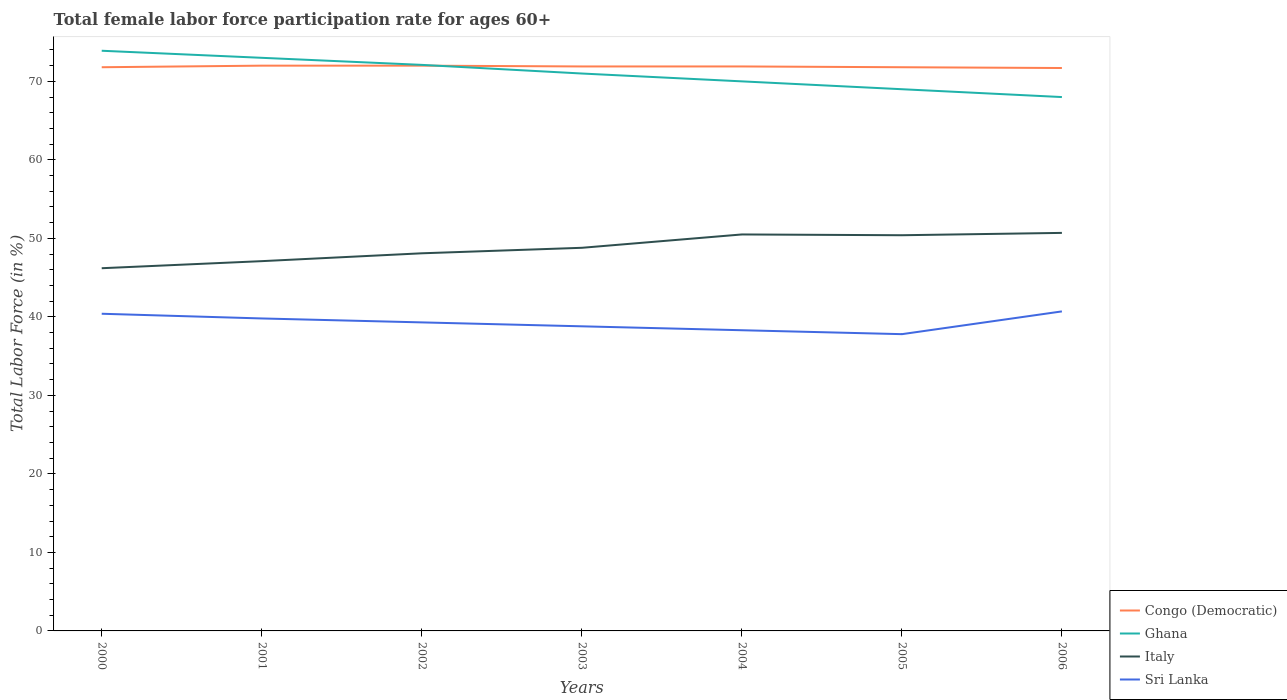How many different coloured lines are there?
Keep it short and to the point. 4. Is the number of lines equal to the number of legend labels?
Your answer should be very brief. Yes. Across all years, what is the maximum female labor force participation rate in Sri Lanka?
Provide a short and direct response. 37.8. What is the total female labor force participation rate in Sri Lanka in the graph?
Make the answer very short. 1. What is the difference between the highest and the second highest female labor force participation rate in Congo (Democratic)?
Provide a short and direct response. 0.3. Is the female labor force participation rate in Congo (Democratic) strictly greater than the female labor force participation rate in Ghana over the years?
Your answer should be very brief. No. How many lines are there?
Keep it short and to the point. 4. Are the values on the major ticks of Y-axis written in scientific E-notation?
Your answer should be very brief. No. Does the graph contain any zero values?
Your answer should be very brief. No. Does the graph contain grids?
Provide a succinct answer. No. How are the legend labels stacked?
Your response must be concise. Vertical. What is the title of the graph?
Ensure brevity in your answer.  Total female labor force participation rate for ages 60+. Does "Uganda" appear as one of the legend labels in the graph?
Give a very brief answer. No. What is the Total Labor Force (in %) in Congo (Democratic) in 2000?
Offer a terse response. 71.8. What is the Total Labor Force (in %) in Ghana in 2000?
Give a very brief answer. 73.9. What is the Total Labor Force (in %) in Italy in 2000?
Ensure brevity in your answer.  46.2. What is the Total Labor Force (in %) in Sri Lanka in 2000?
Offer a very short reply. 40.4. What is the Total Labor Force (in %) in Congo (Democratic) in 2001?
Your response must be concise. 72. What is the Total Labor Force (in %) in Ghana in 2001?
Ensure brevity in your answer.  73. What is the Total Labor Force (in %) of Italy in 2001?
Your answer should be compact. 47.1. What is the Total Labor Force (in %) in Sri Lanka in 2001?
Offer a terse response. 39.8. What is the Total Labor Force (in %) in Congo (Democratic) in 2002?
Give a very brief answer. 72. What is the Total Labor Force (in %) of Ghana in 2002?
Give a very brief answer. 72.1. What is the Total Labor Force (in %) of Italy in 2002?
Your answer should be very brief. 48.1. What is the Total Labor Force (in %) in Sri Lanka in 2002?
Provide a short and direct response. 39.3. What is the Total Labor Force (in %) in Congo (Democratic) in 2003?
Your answer should be very brief. 71.9. What is the Total Labor Force (in %) of Ghana in 2003?
Give a very brief answer. 71. What is the Total Labor Force (in %) of Italy in 2003?
Provide a short and direct response. 48.8. What is the Total Labor Force (in %) of Sri Lanka in 2003?
Provide a short and direct response. 38.8. What is the Total Labor Force (in %) in Congo (Democratic) in 2004?
Provide a short and direct response. 71.9. What is the Total Labor Force (in %) of Italy in 2004?
Provide a succinct answer. 50.5. What is the Total Labor Force (in %) of Sri Lanka in 2004?
Make the answer very short. 38.3. What is the Total Labor Force (in %) in Congo (Democratic) in 2005?
Offer a very short reply. 71.8. What is the Total Labor Force (in %) of Ghana in 2005?
Give a very brief answer. 69. What is the Total Labor Force (in %) in Italy in 2005?
Make the answer very short. 50.4. What is the Total Labor Force (in %) in Sri Lanka in 2005?
Make the answer very short. 37.8. What is the Total Labor Force (in %) in Congo (Democratic) in 2006?
Provide a succinct answer. 71.7. What is the Total Labor Force (in %) of Italy in 2006?
Offer a terse response. 50.7. What is the Total Labor Force (in %) in Sri Lanka in 2006?
Give a very brief answer. 40.7. Across all years, what is the maximum Total Labor Force (in %) in Congo (Democratic)?
Make the answer very short. 72. Across all years, what is the maximum Total Labor Force (in %) of Ghana?
Keep it short and to the point. 73.9. Across all years, what is the maximum Total Labor Force (in %) in Italy?
Make the answer very short. 50.7. Across all years, what is the maximum Total Labor Force (in %) in Sri Lanka?
Provide a succinct answer. 40.7. Across all years, what is the minimum Total Labor Force (in %) of Congo (Democratic)?
Provide a short and direct response. 71.7. Across all years, what is the minimum Total Labor Force (in %) in Italy?
Provide a succinct answer. 46.2. Across all years, what is the minimum Total Labor Force (in %) of Sri Lanka?
Your answer should be very brief. 37.8. What is the total Total Labor Force (in %) of Congo (Democratic) in the graph?
Offer a terse response. 503.1. What is the total Total Labor Force (in %) of Ghana in the graph?
Your answer should be compact. 497. What is the total Total Labor Force (in %) of Italy in the graph?
Your answer should be very brief. 341.8. What is the total Total Labor Force (in %) of Sri Lanka in the graph?
Offer a very short reply. 275.1. What is the difference between the Total Labor Force (in %) of Italy in 2000 and that in 2001?
Your answer should be compact. -0.9. What is the difference between the Total Labor Force (in %) of Sri Lanka in 2000 and that in 2001?
Offer a very short reply. 0.6. What is the difference between the Total Labor Force (in %) in Ghana in 2000 and that in 2002?
Offer a terse response. 1.8. What is the difference between the Total Labor Force (in %) of Italy in 2000 and that in 2002?
Your answer should be very brief. -1.9. What is the difference between the Total Labor Force (in %) of Congo (Democratic) in 2000 and that in 2003?
Keep it short and to the point. -0.1. What is the difference between the Total Labor Force (in %) in Sri Lanka in 2000 and that in 2003?
Provide a short and direct response. 1.6. What is the difference between the Total Labor Force (in %) of Ghana in 2000 and that in 2004?
Offer a terse response. 3.9. What is the difference between the Total Labor Force (in %) of Italy in 2000 and that in 2004?
Your answer should be compact. -4.3. What is the difference between the Total Labor Force (in %) of Sri Lanka in 2000 and that in 2004?
Offer a very short reply. 2.1. What is the difference between the Total Labor Force (in %) of Congo (Democratic) in 2000 and that in 2005?
Your answer should be compact. 0. What is the difference between the Total Labor Force (in %) in Italy in 2000 and that in 2006?
Ensure brevity in your answer.  -4.5. What is the difference between the Total Labor Force (in %) in Sri Lanka in 2001 and that in 2003?
Provide a succinct answer. 1. What is the difference between the Total Labor Force (in %) of Congo (Democratic) in 2001 and that in 2004?
Provide a short and direct response. 0.1. What is the difference between the Total Labor Force (in %) of Italy in 2001 and that in 2004?
Offer a very short reply. -3.4. What is the difference between the Total Labor Force (in %) of Sri Lanka in 2001 and that in 2004?
Your response must be concise. 1.5. What is the difference between the Total Labor Force (in %) in Sri Lanka in 2001 and that in 2006?
Offer a terse response. -0.9. What is the difference between the Total Labor Force (in %) of Congo (Democratic) in 2002 and that in 2003?
Ensure brevity in your answer.  0.1. What is the difference between the Total Labor Force (in %) in Italy in 2002 and that in 2003?
Give a very brief answer. -0.7. What is the difference between the Total Labor Force (in %) of Congo (Democratic) in 2002 and that in 2004?
Make the answer very short. 0.1. What is the difference between the Total Labor Force (in %) in Ghana in 2002 and that in 2004?
Ensure brevity in your answer.  2.1. What is the difference between the Total Labor Force (in %) of Italy in 2002 and that in 2004?
Your answer should be compact. -2.4. What is the difference between the Total Labor Force (in %) of Congo (Democratic) in 2002 and that in 2005?
Ensure brevity in your answer.  0.2. What is the difference between the Total Labor Force (in %) in Ghana in 2002 and that in 2005?
Your answer should be compact. 3.1. What is the difference between the Total Labor Force (in %) of Italy in 2002 and that in 2005?
Keep it short and to the point. -2.3. What is the difference between the Total Labor Force (in %) in Sri Lanka in 2002 and that in 2005?
Offer a very short reply. 1.5. What is the difference between the Total Labor Force (in %) of Italy in 2002 and that in 2006?
Provide a succinct answer. -2.6. What is the difference between the Total Labor Force (in %) of Congo (Democratic) in 2003 and that in 2004?
Offer a terse response. 0. What is the difference between the Total Labor Force (in %) of Ghana in 2003 and that in 2004?
Provide a succinct answer. 1. What is the difference between the Total Labor Force (in %) in Sri Lanka in 2003 and that in 2004?
Give a very brief answer. 0.5. What is the difference between the Total Labor Force (in %) of Ghana in 2003 and that in 2005?
Offer a terse response. 2. What is the difference between the Total Labor Force (in %) in Italy in 2003 and that in 2005?
Offer a very short reply. -1.6. What is the difference between the Total Labor Force (in %) in Sri Lanka in 2003 and that in 2005?
Provide a short and direct response. 1. What is the difference between the Total Labor Force (in %) in Italy in 2003 and that in 2006?
Give a very brief answer. -1.9. What is the difference between the Total Labor Force (in %) in Sri Lanka in 2003 and that in 2006?
Offer a terse response. -1.9. What is the difference between the Total Labor Force (in %) of Ghana in 2004 and that in 2005?
Provide a succinct answer. 1. What is the difference between the Total Labor Force (in %) of Ghana in 2004 and that in 2006?
Provide a succinct answer. 2. What is the difference between the Total Labor Force (in %) of Italy in 2004 and that in 2006?
Your response must be concise. -0.2. What is the difference between the Total Labor Force (in %) in Sri Lanka in 2004 and that in 2006?
Your answer should be compact. -2.4. What is the difference between the Total Labor Force (in %) in Congo (Democratic) in 2005 and that in 2006?
Ensure brevity in your answer.  0.1. What is the difference between the Total Labor Force (in %) in Ghana in 2005 and that in 2006?
Keep it short and to the point. 1. What is the difference between the Total Labor Force (in %) of Congo (Democratic) in 2000 and the Total Labor Force (in %) of Ghana in 2001?
Offer a terse response. -1.2. What is the difference between the Total Labor Force (in %) of Congo (Democratic) in 2000 and the Total Labor Force (in %) of Italy in 2001?
Provide a short and direct response. 24.7. What is the difference between the Total Labor Force (in %) of Congo (Democratic) in 2000 and the Total Labor Force (in %) of Sri Lanka in 2001?
Your response must be concise. 32. What is the difference between the Total Labor Force (in %) in Ghana in 2000 and the Total Labor Force (in %) in Italy in 2001?
Your answer should be compact. 26.8. What is the difference between the Total Labor Force (in %) in Ghana in 2000 and the Total Labor Force (in %) in Sri Lanka in 2001?
Offer a terse response. 34.1. What is the difference between the Total Labor Force (in %) in Italy in 2000 and the Total Labor Force (in %) in Sri Lanka in 2001?
Give a very brief answer. 6.4. What is the difference between the Total Labor Force (in %) of Congo (Democratic) in 2000 and the Total Labor Force (in %) of Italy in 2002?
Keep it short and to the point. 23.7. What is the difference between the Total Labor Force (in %) in Congo (Democratic) in 2000 and the Total Labor Force (in %) in Sri Lanka in 2002?
Provide a short and direct response. 32.5. What is the difference between the Total Labor Force (in %) of Ghana in 2000 and the Total Labor Force (in %) of Italy in 2002?
Offer a very short reply. 25.8. What is the difference between the Total Labor Force (in %) in Ghana in 2000 and the Total Labor Force (in %) in Sri Lanka in 2002?
Give a very brief answer. 34.6. What is the difference between the Total Labor Force (in %) of Italy in 2000 and the Total Labor Force (in %) of Sri Lanka in 2002?
Keep it short and to the point. 6.9. What is the difference between the Total Labor Force (in %) in Congo (Democratic) in 2000 and the Total Labor Force (in %) in Ghana in 2003?
Make the answer very short. 0.8. What is the difference between the Total Labor Force (in %) of Congo (Democratic) in 2000 and the Total Labor Force (in %) of Sri Lanka in 2003?
Ensure brevity in your answer.  33. What is the difference between the Total Labor Force (in %) of Ghana in 2000 and the Total Labor Force (in %) of Italy in 2003?
Your answer should be compact. 25.1. What is the difference between the Total Labor Force (in %) of Ghana in 2000 and the Total Labor Force (in %) of Sri Lanka in 2003?
Ensure brevity in your answer.  35.1. What is the difference between the Total Labor Force (in %) in Italy in 2000 and the Total Labor Force (in %) in Sri Lanka in 2003?
Keep it short and to the point. 7.4. What is the difference between the Total Labor Force (in %) in Congo (Democratic) in 2000 and the Total Labor Force (in %) in Ghana in 2004?
Your answer should be compact. 1.8. What is the difference between the Total Labor Force (in %) in Congo (Democratic) in 2000 and the Total Labor Force (in %) in Italy in 2004?
Offer a very short reply. 21.3. What is the difference between the Total Labor Force (in %) of Congo (Democratic) in 2000 and the Total Labor Force (in %) of Sri Lanka in 2004?
Your answer should be very brief. 33.5. What is the difference between the Total Labor Force (in %) of Ghana in 2000 and the Total Labor Force (in %) of Italy in 2004?
Make the answer very short. 23.4. What is the difference between the Total Labor Force (in %) in Ghana in 2000 and the Total Labor Force (in %) in Sri Lanka in 2004?
Keep it short and to the point. 35.6. What is the difference between the Total Labor Force (in %) in Italy in 2000 and the Total Labor Force (in %) in Sri Lanka in 2004?
Offer a very short reply. 7.9. What is the difference between the Total Labor Force (in %) of Congo (Democratic) in 2000 and the Total Labor Force (in %) of Ghana in 2005?
Provide a short and direct response. 2.8. What is the difference between the Total Labor Force (in %) in Congo (Democratic) in 2000 and the Total Labor Force (in %) in Italy in 2005?
Provide a short and direct response. 21.4. What is the difference between the Total Labor Force (in %) of Congo (Democratic) in 2000 and the Total Labor Force (in %) of Sri Lanka in 2005?
Your answer should be compact. 34. What is the difference between the Total Labor Force (in %) of Ghana in 2000 and the Total Labor Force (in %) of Sri Lanka in 2005?
Keep it short and to the point. 36.1. What is the difference between the Total Labor Force (in %) of Italy in 2000 and the Total Labor Force (in %) of Sri Lanka in 2005?
Give a very brief answer. 8.4. What is the difference between the Total Labor Force (in %) in Congo (Democratic) in 2000 and the Total Labor Force (in %) in Ghana in 2006?
Offer a very short reply. 3.8. What is the difference between the Total Labor Force (in %) in Congo (Democratic) in 2000 and the Total Labor Force (in %) in Italy in 2006?
Make the answer very short. 21.1. What is the difference between the Total Labor Force (in %) of Congo (Democratic) in 2000 and the Total Labor Force (in %) of Sri Lanka in 2006?
Offer a terse response. 31.1. What is the difference between the Total Labor Force (in %) of Ghana in 2000 and the Total Labor Force (in %) of Italy in 2006?
Give a very brief answer. 23.2. What is the difference between the Total Labor Force (in %) in Ghana in 2000 and the Total Labor Force (in %) in Sri Lanka in 2006?
Provide a succinct answer. 33.2. What is the difference between the Total Labor Force (in %) of Congo (Democratic) in 2001 and the Total Labor Force (in %) of Italy in 2002?
Offer a very short reply. 23.9. What is the difference between the Total Labor Force (in %) of Congo (Democratic) in 2001 and the Total Labor Force (in %) of Sri Lanka in 2002?
Offer a very short reply. 32.7. What is the difference between the Total Labor Force (in %) in Ghana in 2001 and the Total Labor Force (in %) in Italy in 2002?
Provide a succinct answer. 24.9. What is the difference between the Total Labor Force (in %) of Ghana in 2001 and the Total Labor Force (in %) of Sri Lanka in 2002?
Offer a very short reply. 33.7. What is the difference between the Total Labor Force (in %) of Congo (Democratic) in 2001 and the Total Labor Force (in %) of Ghana in 2003?
Provide a succinct answer. 1. What is the difference between the Total Labor Force (in %) in Congo (Democratic) in 2001 and the Total Labor Force (in %) in Italy in 2003?
Make the answer very short. 23.2. What is the difference between the Total Labor Force (in %) in Congo (Democratic) in 2001 and the Total Labor Force (in %) in Sri Lanka in 2003?
Ensure brevity in your answer.  33.2. What is the difference between the Total Labor Force (in %) of Ghana in 2001 and the Total Labor Force (in %) of Italy in 2003?
Give a very brief answer. 24.2. What is the difference between the Total Labor Force (in %) in Ghana in 2001 and the Total Labor Force (in %) in Sri Lanka in 2003?
Provide a short and direct response. 34.2. What is the difference between the Total Labor Force (in %) in Italy in 2001 and the Total Labor Force (in %) in Sri Lanka in 2003?
Give a very brief answer. 8.3. What is the difference between the Total Labor Force (in %) of Congo (Democratic) in 2001 and the Total Labor Force (in %) of Sri Lanka in 2004?
Offer a terse response. 33.7. What is the difference between the Total Labor Force (in %) of Ghana in 2001 and the Total Labor Force (in %) of Italy in 2004?
Give a very brief answer. 22.5. What is the difference between the Total Labor Force (in %) in Ghana in 2001 and the Total Labor Force (in %) in Sri Lanka in 2004?
Make the answer very short. 34.7. What is the difference between the Total Labor Force (in %) in Congo (Democratic) in 2001 and the Total Labor Force (in %) in Italy in 2005?
Offer a very short reply. 21.6. What is the difference between the Total Labor Force (in %) of Congo (Democratic) in 2001 and the Total Labor Force (in %) of Sri Lanka in 2005?
Your answer should be compact. 34.2. What is the difference between the Total Labor Force (in %) in Ghana in 2001 and the Total Labor Force (in %) in Italy in 2005?
Provide a short and direct response. 22.6. What is the difference between the Total Labor Force (in %) in Ghana in 2001 and the Total Labor Force (in %) in Sri Lanka in 2005?
Ensure brevity in your answer.  35.2. What is the difference between the Total Labor Force (in %) of Italy in 2001 and the Total Labor Force (in %) of Sri Lanka in 2005?
Offer a terse response. 9.3. What is the difference between the Total Labor Force (in %) of Congo (Democratic) in 2001 and the Total Labor Force (in %) of Ghana in 2006?
Your answer should be very brief. 4. What is the difference between the Total Labor Force (in %) in Congo (Democratic) in 2001 and the Total Labor Force (in %) in Italy in 2006?
Offer a very short reply. 21.3. What is the difference between the Total Labor Force (in %) in Congo (Democratic) in 2001 and the Total Labor Force (in %) in Sri Lanka in 2006?
Keep it short and to the point. 31.3. What is the difference between the Total Labor Force (in %) in Ghana in 2001 and the Total Labor Force (in %) in Italy in 2006?
Offer a terse response. 22.3. What is the difference between the Total Labor Force (in %) of Ghana in 2001 and the Total Labor Force (in %) of Sri Lanka in 2006?
Provide a succinct answer. 32.3. What is the difference between the Total Labor Force (in %) in Italy in 2001 and the Total Labor Force (in %) in Sri Lanka in 2006?
Offer a terse response. 6.4. What is the difference between the Total Labor Force (in %) of Congo (Democratic) in 2002 and the Total Labor Force (in %) of Italy in 2003?
Offer a terse response. 23.2. What is the difference between the Total Labor Force (in %) of Congo (Democratic) in 2002 and the Total Labor Force (in %) of Sri Lanka in 2003?
Keep it short and to the point. 33.2. What is the difference between the Total Labor Force (in %) of Ghana in 2002 and the Total Labor Force (in %) of Italy in 2003?
Your answer should be very brief. 23.3. What is the difference between the Total Labor Force (in %) of Ghana in 2002 and the Total Labor Force (in %) of Sri Lanka in 2003?
Your answer should be compact. 33.3. What is the difference between the Total Labor Force (in %) of Italy in 2002 and the Total Labor Force (in %) of Sri Lanka in 2003?
Ensure brevity in your answer.  9.3. What is the difference between the Total Labor Force (in %) of Congo (Democratic) in 2002 and the Total Labor Force (in %) of Italy in 2004?
Ensure brevity in your answer.  21.5. What is the difference between the Total Labor Force (in %) in Congo (Democratic) in 2002 and the Total Labor Force (in %) in Sri Lanka in 2004?
Your answer should be compact. 33.7. What is the difference between the Total Labor Force (in %) in Ghana in 2002 and the Total Labor Force (in %) in Italy in 2004?
Provide a succinct answer. 21.6. What is the difference between the Total Labor Force (in %) of Ghana in 2002 and the Total Labor Force (in %) of Sri Lanka in 2004?
Offer a terse response. 33.8. What is the difference between the Total Labor Force (in %) in Congo (Democratic) in 2002 and the Total Labor Force (in %) in Ghana in 2005?
Ensure brevity in your answer.  3. What is the difference between the Total Labor Force (in %) of Congo (Democratic) in 2002 and the Total Labor Force (in %) of Italy in 2005?
Provide a succinct answer. 21.6. What is the difference between the Total Labor Force (in %) of Congo (Democratic) in 2002 and the Total Labor Force (in %) of Sri Lanka in 2005?
Your answer should be compact. 34.2. What is the difference between the Total Labor Force (in %) of Ghana in 2002 and the Total Labor Force (in %) of Italy in 2005?
Keep it short and to the point. 21.7. What is the difference between the Total Labor Force (in %) of Ghana in 2002 and the Total Labor Force (in %) of Sri Lanka in 2005?
Keep it short and to the point. 34.3. What is the difference between the Total Labor Force (in %) in Italy in 2002 and the Total Labor Force (in %) in Sri Lanka in 2005?
Make the answer very short. 10.3. What is the difference between the Total Labor Force (in %) in Congo (Democratic) in 2002 and the Total Labor Force (in %) in Italy in 2006?
Your answer should be compact. 21.3. What is the difference between the Total Labor Force (in %) of Congo (Democratic) in 2002 and the Total Labor Force (in %) of Sri Lanka in 2006?
Provide a short and direct response. 31.3. What is the difference between the Total Labor Force (in %) of Ghana in 2002 and the Total Labor Force (in %) of Italy in 2006?
Give a very brief answer. 21.4. What is the difference between the Total Labor Force (in %) in Ghana in 2002 and the Total Labor Force (in %) in Sri Lanka in 2006?
Ensure brevity in your answer.  31.4. What is the difference between the Total Labor Force (in %) of Congo (Democratic) in 2003 and the Total Labor Force (in %) of Ghana in 2004?
Offer a very short reply. 1.9. What is the difference between the Total Labor Force (in %) in Congo (Democratic) in 2003 and the Total Labor Force (in %) in Italy in 2004?
Your answer should be very brief. 21.4. What is the difference between the Total Labor Force (in %) in Congo (Democratic) in 2003 and the Total Labor Force (in %) in Sri Lanka in 2004?
Offer a terse response. 33.6. What is the difference between the Total Labor Force (in %) of Ghana in 2003 and the Total Labor Force (in %) of Italy in 2004?
Offer a terse response. 20.5. What is the difference between the Total Labor Force (in %) of Ghana in 2003 and the Total Labor Force (in %) of Sri Lanka in 2004?
Your answer should be very brief. 32.7. What is the difference between the Total Labor Force (in %) in Congo (Democratic) in 2003 and the Total Labor Force (in %) in Ghana in 2005?
Provide a succinct answer. 2.9. What is the difference between the Total Labor Force (in %) in Congo (Democratic) in 2003 and the Total Labor Force (in %) in Italy in 2005?
Give a very brief answer. 21.5. What is the difference between the Total Labor Force (in %) of Congo (Democratic) in 2003 and the Total Labor Force (in %) of Sri Lanka in 2005?
Your answer should be compact. 34.1. What is the difference between the Total Labor Force (in %) of Ghana in 2003 and the Total Labor Force (in %) of Italy in 2005?
Your response must be concise. 20.6. What is the difference between the Total Labor Force (in %) of Ghana in 2003 and the Total Labor Force (in %) of Sri Lanka in 2005?
Provide a short and direct response. 33.2. What is the difference between the Total Labor Force (in %) in Italy in 2003 and the Total Labor Force (in %) in Sri Lanka in 2005?
Provide a short and direct response. 11. What is the difference between the Total Labor Force (in %) in Congo (Democratic) in 2003 and the Total Labor Force (in %) in Italy in 2006?
Make the answer very short. 21.2. What is the difference between the Total Labor Force (in %) in Congo (Democratic) in 2003 and the Total Labor Force (in %) in Sri Lanka in 2006?
Offer a terse response. 31.2. What is the difference between the Total Labor Force (in %) of Ghana in 2003 and the Total Labor Force (in %) of Italy in 2006?
Your response must be concise. 20.3. What is the difference between the Total Labor Force (in %) of Ghana in 2003 and the Total Labor Force (in %) of Sri Lanka in 2006?
Give a very brief answer. 30.3. What is the difference between the Total Labor Force (in %) in Congo (Democratic) in 2004 and the Total Labor Force (in %) in Italy in 2005?
Provide a short and direct response. 21.5. What is the difference between the Total Labor Force (in %) in Congo (Democratic) in 2004 and the Total Labor Force (in %) in Sri Lanka in 2005?
Ensure brevity in your answer.  34.1. What is the difference between the Total Labor Force (in %) of Ghana in 2004 and the Total Labor Force (in %) of Italy in 2005?
Give a very brief answer. 19.6. What is the difference between the Total Labor Force (in %) in Ghana in 2004 and the Total Labor Force (in %) in Sri Lanka in 2005?
Ensure brevity in your answer.  32.2. What is the difference between the Total Labor Force (in %) in Italy in 2004 and the Total Labor Force (in %) in Sri Lanka in 2005?
Your response must be concise. 12.7. What is the difference between the Total Labor Force (in %) of Congo (Democratic) in 2004 and the Total Labor Force (in %) of Italy in 2006?
Your answer should be very brief. 21.2. What is the difference between the Total Labor Force (in %) in Congo (Democratic) in 2004 and the Total Labor Force (in %) in Sri Lanka in 2006?
Offer a terse response. 31.2. What is the difference between the Total Labor Force (in %) of Ghana in 2004 and the Total Labor Force (in %) of Italy in 2006?
Provide a short and direct response. 19.3. What is the difference between the Total Labor Force (in %) in Ghana in 2004 and the Total Labor Force (in %) in Sri Lanka in 2006?
Give a very brief answer. 29.3. What is the difference between the Total Labor Force (in %) of Italy in 2004 and the Total Labor Force (in %) of Sri Lanka in 2006?
Give a very brief answer. 9.8. What is the difference between the Total Labor Force (in %) of Congo (Democratic) in 2005 and the Total Labor Force (in %) of Italy in 2006?
Your answer should be very brief. 21.1. What is the difference between the Total Labor Force (in %) of Congo (Democratic) in 2005 and the Total Labor Force (in %) of Sri Lanka in 2006?
Your answer should be compact. 31.1. What is the difference between the Total Labor Force (in %) in Ghana in 2005 and the Total Labor Force (in %) in Sri Lanka in 2006?
Give a very brief answer. 28.3. What is the average Total Labor Force (in %) in Congo (Democratic) per year?
Give a very brief answer. 71.87. What is the average Total Labor Force (in %) in Ghana per year?
Your answer should be compact. 71. What is the average Total Labor Force (in %) in Italy per year?
Offer a very short reply. 48.83. What is the average Total Labor Force (in %) of Sri Lanka per year?
Provide a short and direct response. 39.3. In the year 2000, what is the difference between the Total Labor Force (in %) in Congo (Democratic) and Total Labor Force (in %) in Ghana?
Keep it short and to the point. -2.1. In the year 2000, what is the difference between the Total Labor Force (in %) in Congo (Democratic) and Total Labor Force (in %) in Italy?
Make the answer very short. 25.6. In the year 2000, what is the difference between the Total Labor Force (in %) in Congo (Democratic) and Total Labor Force (in %) in Sri Lanka?
Your answer should be compact. 31.4. In the year 2000, what is the difference between the Total Labor Force (in %) of Ghana and Total Labor Force (in %) of Italy?
Ensure brevity in your answer.  27.7. In the year 2000, what is the difference between the Total Labor Force (in %) in Ghana and Total Labor Force (in %) in Sri Lanka?
Your answer should be very brief. 33.5. In the year 2001, what is the difference between the Total Labor Force (in %) in Congo (Democratic) and Total Labor Force (in %) in Ghana?
Give a very brief answer. -1. In the year 2001, what is the difference between the Total Labor Force (in %) in Congo (Democratic) and Total Labor Force (in %) in Italy?
Your answer should be very brief. 24.9. In the year 2001, what is the difference between the Total Labor Force (in %) of Congo (Democratic) and Total Labor Force (in %) of Sri Lanka?
Provide a succinct answer. 32.2. In the year 2001, what is the difference between the Total Labor Force (in %) in Ghana and Total Labor Force (in %) in Italy?
Offer a very short reply. 25.9. In the year 2001, what is the difference between the Total Labor Force (in %) of Ghana and Total Labor Force (in %) of Sri Lanka?
Give a very brief answer. 33.2. In the year 2001, what is the difference between the Total Labor Force (in %) of Italy and Total Labor Force (in %) of Sri Lanka?
Ensure brevity in your answer.  7.3. In the year 2002, what is the difference between the Total Labor Force (in %) of Congo (Democratic) and Total Labor Force (in %) of Ghana?
Your response must be concise. -0.1. In the year 2002, what is the difference between the Total Labor Force (in %) of Congo (Democratic) and Total Labor Force (in %) of Italy?
Offer a very short reply. 23.9. In the year 2002, what is the difference between the Total Labor Force (in %) of Congo (Democratic) and Total Labor Force (in %) of Sri Lanka?
Offer a terse response. 32.7. In the year 2002, what is the difference between the Total Labor Force (in %) of Ghana and Total Labor Force (in %) of Sri Lanka?
Offer a terse response. 32.8. In the year 2002, what is the difference between the Total Labor Force (in %) in Italy and Total Labor Force (in %) in Sri Lanka?
Make the answer very short. 8.8. In the year 2003, what is the difference between the Total Labor Force (in %) of Congo (Democratic) and Total Labor Force (in %) of Ghana?
Your answer should be very brief. 0.9. In the year 2003, what is the difference between the Total Labor Force (in %) in Congo (Democratic) and Total Labor Force (in %) in Italy?
Offer a very short reply. 23.1. In the year 2003, what is the difference between the Total Labor Force (in %) in Congo (Democratic) and Total Labor Force (in %) in Sri Lanka?
Your answer should be very brief. 33.1. In the year 2003, what is the difference between the Total Labor Force (in %) in Ghana and Total Labor Force (in %) in Italy?
Offer a very short reply. 22.2. In the year 2003, what is the difference between the Total Labor Force (in %) of Ghana and Total Labor Force (in %) of Sri Lanka?
Give a very brief answer. 32.2. In the year 2004, what is the difference between the Total Labor Force (in %) in Congo (Democratic) and Total Labor Force (in %) in Italy?
Offer a very short reply. 21.4. In the year 2004, what is the difference between the Total Labor Force (in %) of Congo (Democratic) and Total Labor Force (in %) of Sri Lanka?
Offer a very short reply. 33.6. In the year 2004, what is the difference between the Total Labor Force (in %) in Ghana and Total Labor Force (in %) in Italy?
Give a very brief answer. 19.5. In the year 2004, what is the difference between the Total Labor Force (in %) of Ghana and Total Labor Force (in %) of Sri Lanka?
Your response must be concise. 31.7. In the year 2005, what is the difference between the Total Labor Force (in %) in Congo (Democratic) and Total Labor Force (in %) in Italy?
Ensure brevity in your answer.  21.4. In the year 2005, what is the difference between the Total Labor Force (in %) in Congo (Democratic) and Total Labor Force (in %) in Sri Lanka?
Make the answer very short. 34. In the year 2005, what is the difference between the Total Labor Force (in %) in Ghana and Total Labor Force (in %) in Sri Lanka?
Provide a succinct answer. 31.2. In the year 2006, what is the difference between the Total Labor Force (in %) of Congo (Democratic) and Total Labor Force (in %) of Italy?
Offer a terse response. 21. In the year 2006, what is the difference between the Total Labor Force (in %) of Congo (Democratic) and Total Labor Force (in %) of Sri Lanka?
Provide a succinct answer. 31. In the year 2006, what is the difference between the Total Labor Force (in %) of Ghana and Total Labor Force (in %) of Sri Lanka?
Your answer should be very brief. 27.3. In the year 2006, what is the difference between the Total Labor Force (in %) of Italy and Total Labor Force (in %) of Sri Lanka?
Your answer should be compact. 10. What is the ratio of the Total Labor Force (in %) in Ghana in 2000 to that in 2001?
Your answer should be very brief. 1.01. What is the ratio of the Total Labor Force (in %) of Italy in 2000 to that in 2001?
Your answer should be very brief. 0.98. What is the ratio of the Total Labor Force (in %) of Sri Lanka in 2000 to that in 2001?
Ensure brevity in your answer.  1.02. What is the ratio of the Total Labor Force (in %) in Congo (Democratic) in 2000 to that in 2002?
Provide a short and direct response. 1. What is the ratio of the Total Labor Force (in %) of Italy in 2000 to that in 2002?
Your answer should be very brief. 0.96. What is the ratio of the Total Labor Force (in %) of Sri Lanka in 2000 to that in 2002?
Provide a succinct answer. 1.03. What is the ratio of the Total Labor Force (in %) in Congo (Democratic) in 2000 to that in 2003?
Provide a short and direct response. 1. What is the ratio of the Total Labor Force (in %) of Ghana in 2000 to that in 2003?
Your answer should be very brief. 1.04. What is the ratio of the Total Labor Force (in %) in Italy in 2000 to that in 2003?
Make the answer very short. 0.95. What is the ratio of the Total Labor Force (in %) of Sri Lanka in 2000 to that in 2003?
Your answer should be compact. 1.04. What is the ratio of the Total Labor Force (in %) in Ghana in 2000 to that in 2004?
Keep it short and to the point. 1.06. What is the ratio of the Total Labor Force (in %) in Italy in 2000 to that in 2004?
Your answer should be compact. 0.91. What is the ratio of the Total Labor Force (in %) of Sri Lanka in 2000 to that in 2004?
Your response must be concise. 1.05. What is the ratio of the Total Labor Force (in %) in Congo (Democratic) in 2000 to that in 2005?
Keep it short and to the point. 1. What is the ratio of the Total Labor Force (in %) in Ghana in 2000 to that in 2005?
Provide a short and direct response. 1.07. What is the ratio of the Total Labor Force (in %) of Italy in 2000 to that in 2005?
Your answer should be compact. 0.92. What is the ratio of the Total Labor Force (in %) of Sri Lanka in 2000 to that in 2005?
Offer a terse response. 1.07. What is the ratio of the Total Labor Force (in %) of Ghana in 2000 to that in 2006?
Your response must be concise. 1.09. What is the ratio of the Total Labor Force (in %) in Italy in 2000 to that in 2006?
Offer a terse response. 0.91. What is the ratio of the Total Labor Force (in %) of Congo (Democratic) in 2001 to that in 2002?
Offer a terse response. 1. What is the ratio of the Total Labor Force (in %) of Ghana in 2001 to that in 2002?
Ensure brevity in your answer.  1.01. What is the ratio of the Total Labor Force (in %) in Italy in 2001 to that in 2002?
Your response must be concise. 0.98. What is the ratio of the Total Labor Force (in %) in Sri Lanka in 2001 to that in 2002?
Your answer should be very brief. 1.01. What is the ratio of the Total Labor Force (in %) of Ghana in 2001 to that in 2003?
Your answer should be compact. 1.03. What is the ratio of the Total Labor Force (in %) in Italy in 2001 to that in 2003?
Your response must be concise. 0.97. What is the ratio of the Total Labor Force (in %) of Sri Lanka in 2001 to that in 2003?
Ensure brevity in your answer.  1.03. What is the ratio of the Total Labor Force (in %) in Congo (Democratic) in 2001 to that in 2004?
Ensure brevity in your answer.  1. What is the ratio of the Total Labor Force (in %) in Ghana in 2001 to that in 2004?
Give a very brief answer. 1.04. What is the ratio of the Total Labor Force (in %) of Italy in 2001 to that in 2004?
Provide a short and direct response. 0.93. What is the ratio of the Total Labor Force (in %) in Sri Lanka in 2001 to that in 2004?
Give a very brief answer. 1.04. What is the ratio of the Total Labor Force (in %) in Congo (Democratic) in 2001 to that in 2005?
Your answer should be compact. 1. What is the ratio of the Total Labor Force (in %) of Ghana in 2001 to that in 2005?
Keep it short and to the point. 1.06. What is the ratio of the Total Labor Force (in %) of Italy in 2001 to that in 2005?
Ensure brevity in your answer.  0.93. What is the ratio of the Total Labor Force (in %) of Sri Lanka in 2001 to that in 2005?
Ensure brevity in your answer.  1.05. What is the ratio of the Total Labor Force (in %) in Congo (Democratic) in 2001 to that in 2006?
Your response must be concise. 1. What is the ratio of the Total Labor Force (in %) in Ghana in 2001 to that in 2006?
Your answer should be compact. 1.07. What is the ratio of the Total Labor Force (in %) in Italy in 2001 to that in 2006?
Keep it short and to the point. 0.93. What is the ratio of the Total Labor Force (in %) in Sri Lanka in 2001 to that in 2006?
Provide a succinct answer. 0.98. What is the ratio of the Total Labor Force (in %) in Congo (Democratic) in 2002 to that in 2003?
Provide a succinct answer. 1. What is the ratio of the Total Labor Force (in %) in Ghana in 2002 to that in 2003?
Ensure brevity in your answer.  1.02. What is the ratio of the Total Labor Force (in %) of Italy in 2002 to that in 2003?
Give a very brief answer. 0.99. What is the ratio of the Total Labor Force (in %) in Sri Lanka in 2002 to that in 2003?
Give a very brief answer. 1.01. What is the ratio of the Total Labor Force (in %) of Congo (Democratic) in 2002 to that in 2004?
Ensure brevity in your answer.  1. What is the ratio of the Total Labor Force (in %) of Italy in 2002 to that in 2004?
Give a very brief answer. 0.95. What is the ratio of the Total Labor Force (in %) in Sri Lanka in 2002 to that in 2004?
Your response must be concise. 1.03. What is the ratio of the Total Labor Force (in %) in Congo (Democratic) in 2002 to that in 2005?
Provide a short and direct response. 1. What is the ratio of the Total Labor Force (in %) in Ghana in 2002 to that in 2005?
Give a very brief answer. 1.04. What is the ratio of the Total Labor Force (in %) in Italy in 2002 to that in 2005?
Your response must be concise. 0.95. What is the ratio of the Total Labor Force (in %) in Sri Lanka in 2002 to that in 2005?
Your answer should be very brief. 1.04. What is the ratio of the Total Labor Force (in %) of Congo (Democratic) in 2002 to that in 2006?
Provide a short and direct response. 1. What is the ratio of the Total Labor Force (in %) in Ghana in 2002 to that in 2006?
Give a very brief answer. 1.06. What is the ratio of the Total Labor Force (in %) of Italy in 2002 to that in 2006?
Your answer should be compact. 0.95. What is the ratio of the Total Labor Force (in %) of Sri Lanka in 2002 to that in 2006?
Provide a succinct answer. 0.97. What is the ratio of the Total Labor Force (in %) in Ghana in 2003 to that in 2004?
Your answer should be compact. 1.01. What is the ratio of the Total Labor Force (in %) in Italy in 2003 to that in 2004?
Your answer should be compact. 0.97. What is the ratio of the Total Labor Force (in %) in Sri Lanka in 2003 to that in 2004?
Make the answer very short. 1.01. What is the ratio of the Total Labor Force (in %) of Congo (Democratic) in 2003 to that in 2005?
Your response must be concise. 1. What is the ratio of the Total Labor Force (in %) of Italy in 2003 to that in 2005?
Make the answer very short. 0.97. What is the ratio of the Total Labor Force (in %) in Sri Lanka in 2003 to that in 2005?
Your answer should be very brief. 1.03. What is the ratio of the Total Labor Force (in %) of Ghana in 2003 to that in 2006?
Make the answer very short. 1.04. What is the ratio of the Total Labor Force (in %) of Italy in 2003 to that in 2006?
Your response must be concise. 0.96. What is the ratio of the Total Labor Force (in %) of Sri Lanka in 2003 to that in 2006?
Provide a succinct answer. 0.95. What is the ratio of the Total Labor Force (in %) in Congo (Democratic) in 2004 to that in 2005?
Keep it short and to the point. 1. What is the ratio of the Total Labor Force (in %) of Ghana in 2004 to that in 2005?
Keep it short and to the point. 1.01. What is the ratio of the Total Labor Force (in %) of Sri Lanka in 2004 to that in 2005?
Make the answer very short. 1.01. What is the ratio of the Total Labor Force (in %) in Congo (Democratic) in 2004 to that in 2006?
Offer a terse response. 1. What is the ratio of the Total Labor Force (in %) of Ghana in 2004 to that in 2006?
Your answer should be compact. 1.03. What is the ratio of the Total Labor Force (in %) in Italy in 2004 to that in 2006?
Ensure brevity in your answer.  1. What is the ratio of the Total Labor Force (in %) of Sri Lanka in 2004 to that in 2006?
Your response must be concise. 0.94. What is the ratio of the Total Labor Force (in %) of Congo (Democratic) in 2005 to that in 2006?
Your response must be concise. 1. What is the ratio of the Total Labor Force (in %) of Ghana in 2005 to that in 2006?
Keep it short and to the point. 1.01. What is the ratio of the Total Labor Force (in %) in Italy in 2005 to that in 2006?
Provide a succinct answer. 0.99. What is the ratio of the Total Labor Force (in %) in Sri Lanka in 2005 to that in 2006?
Provide a short and direct response. 0.93. What is the difference between the highest and the second highest Total Labor Force (in %) in Congo (Democratic)?
Keep it short and to the point. 0. What is the difference between the highest and the second highest Total Labor Force (in %) of Ghana?
Ensure brevity in your answer.  0.9. What is the difference between the highest and the second highest Total Labor Force (in %) in Sri Lanka?
Offer a terse response. 0.3. What is the difference between the highest and the lowest Total Labor Force (in %) of Italy?
Keep it short and to the point. 4.5. What is the difference between the highest and the lowest Total Labor Force (in %) of Sri Lanka?
Offer a very short reply. 2.9. 